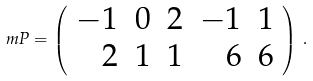<formula> <loc_0><loc_0><loc_500><loc_500>\ m P = \left ( \begin{array} { r r r r r } - 1 & 0 & 2 & - 1 & 1 \\ 2 & 1 & 1 & 6 & 6 \end{array} \right ) \, .</formula> 